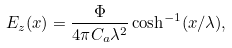Convert formula to latex. <formula><loc_0><loc_0><loc_500><loc_500>E _ { z } ( x ) = \frac { \Phi } { 4 \pi C _ { a } \lambda ^ { 2 } } \cosh ^ { - 1 } ( x / \lambda ) ,</formula> 